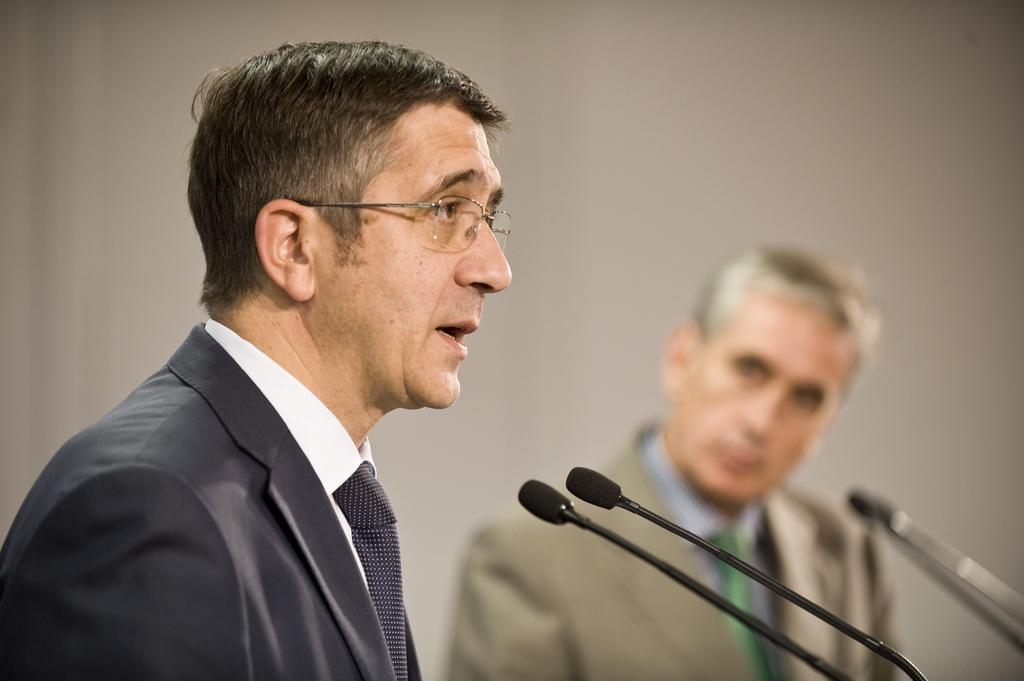How many men are in the image? There are two men in the image. What are the men wearing? Both men are wearing blazers and ties. What objects are in front of the men? There are microphones in front of the men. What can be seen in the background of the image? There is a wall visible in the background of the image. What type of verse can be heard being recited by the men in the image? There is no indication in the image that the men are reciting any verse, so it cannot be determined from the picture. 